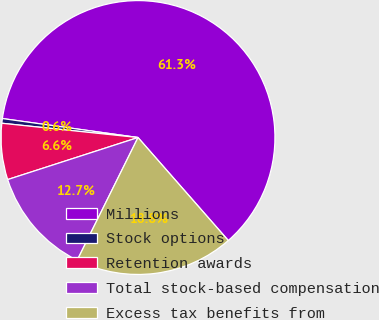Convert chart. <chart><loc_0><loc_0><loc_500><loc_500><pie_chart><fcel>Millions<fcel>Stock options<fcel>Retention awards<fcel>Total stock-based compensation<fcel>Excess tax benefits from<nl><fcel>61.33%<fcel>0.55%<fcel>6.63%<fcel>12.71%<fcel>18.78%<nl></chart> 